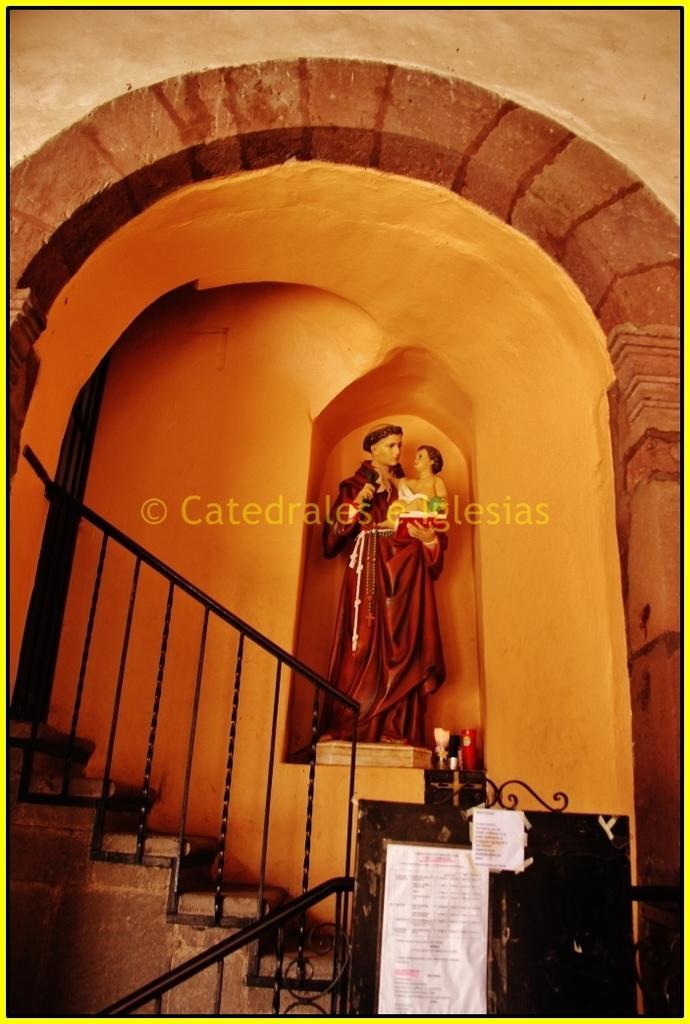Can you describe this image briefly? In this image I can see the podium and the white color paper is attached to it. To the left there are stairs and the railing. In the back I can see the statue which is in maroon color. It is inside the building. 